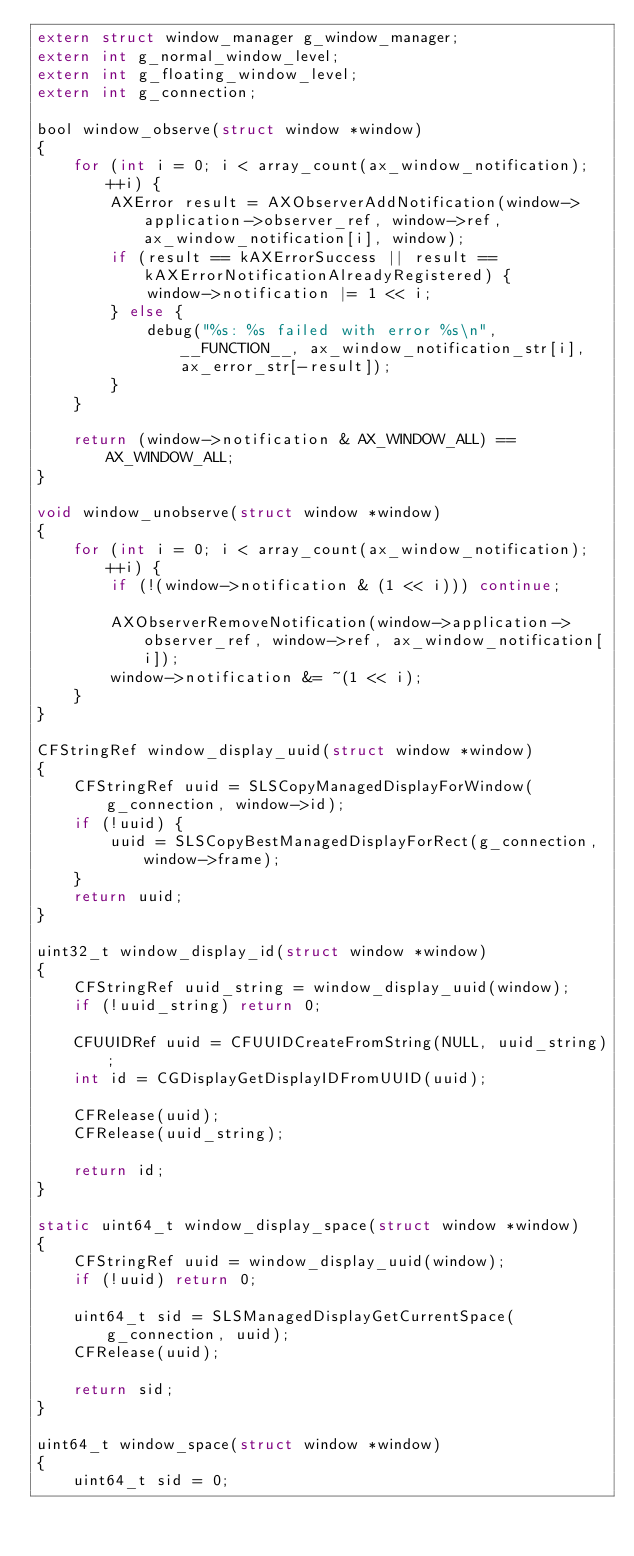Convert code to text. <code><loc_0><loc_0><loc_500><loc_500><_C_>extern struct window_manager g_window_manager;
extern int g_normal_window_level;
extern int g_floating_window_level;
extern int g_connection;

bool window_observe(struct window *window)
{
    for (int i = 0; i < array_count(ax_window_notification); ++i) {
        AXError result = AXObserverAddNotification(window->application->observer_ref, window->ref, ax_window_notification[i], window);
        if (result == kAXErrorSuccess || result == kAXErrorNotificationAlreadyRegistered) {
            window->notification |= 1 << i;
        } else {
            debug("%s: %s failed with error %s\n", __FUNCTION__, ax_window_notification_str[i], ax_error_str[-result]);
        }
    }

    return (window->notification & AX_WINDOW_ALL) == AX_WINDOW_ALL;
}

void window_unobserve(struct window *window)
{
    for (int i = 0; i < array_count(ax_window_notification); ++i) {
        if (!(window->notification & (1 << i))) continue;

        AXObserverRemoveNotification(window->application->observer_ref, window->ref, ax_window_notification[i]);
        window->notification &= ~(1 << i);
    }
}

CFStringRef window_display_uuid(struct window *window)
{
    CFStringRef uuid = SLSCopyManagedDisplayForWindow(g_connection, window->id);
    if (!uuid) {
        uuid = SLSCopyBestManagedDisplayForRect(g_connection, window->frame);
    }
    return uuid;
}

uint32_t window_display_id(struct window *window)
{
    CFStringRef uuid_string = window_display_uuid(window);
    if (!uuid_string) return 0;

    CFUUIDRef uuid = CFUUIDCreateFromString(NULL, uuid_string);
    int id = CGDisplayGetDisplayIDFromUUID(uuid);

    CFRelease(uuid);
    CFRelease(uuid_string);

    return id;
}

static uint64_t window_display_space(struct window *window)
{
    CFStringRef uuid = window_display_uuid(window);
    if (!uuid) return 0;

    uint64_t sid = SLSManagedDisplayGetCurrentSpace(g_connection, uuid);
    CFRelease(uuid);

    return sid;
}

uint64_t window_space(struct window *window)
{
    uint64_t sid = 0;
</code> 